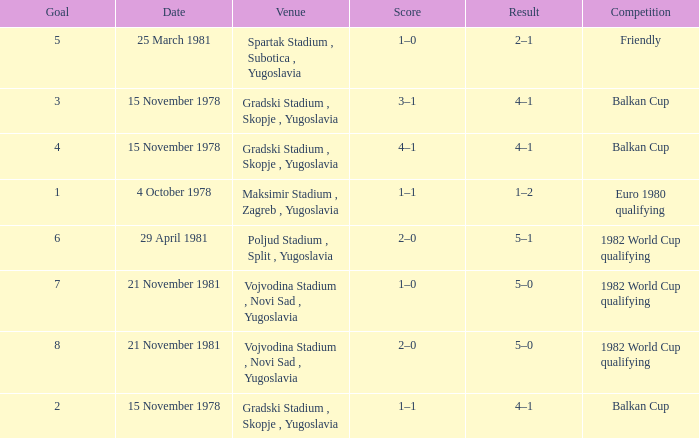What is the Result for Goal 3? 4–1. 